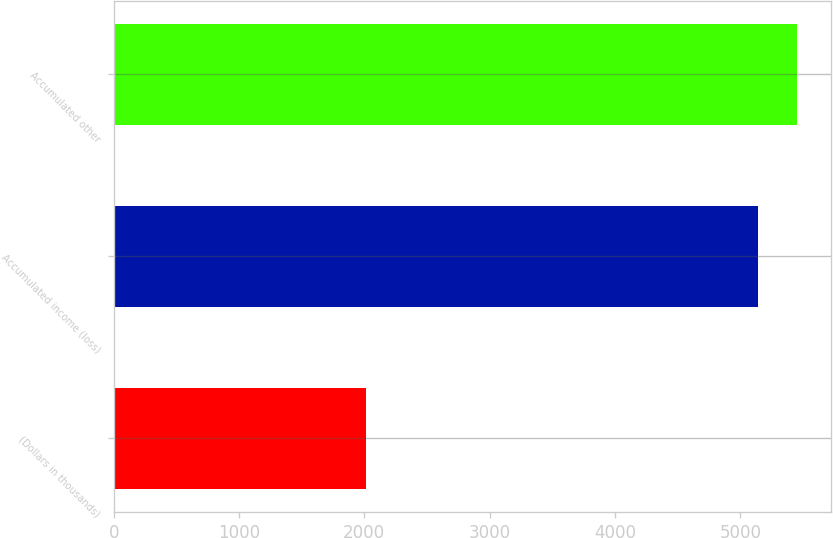Convert chart to OTSL. <chart><loc_0><loc_0><loc_500><loc_500><bar_chart><fcel>(Dollars in thousands)<fcel>Accumulated income (loss)<fcel>Accumulated other<nl><fcel>2015<fcel>5139<fcel>5451.4<nl></chart> 